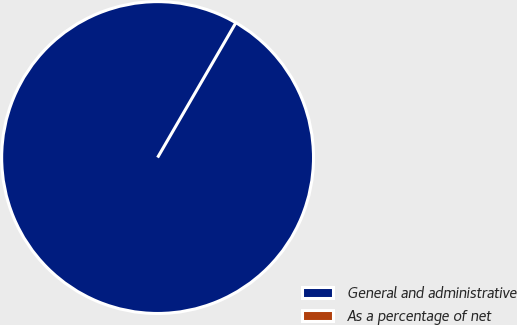<chart> <loc_0><loc_0><loc_500><loc_500><pie_chart><fcel>General and administrative<fcel>As a percentage of net<nl><fcel>100.0%<fcel>0.0%<nl></chart> 